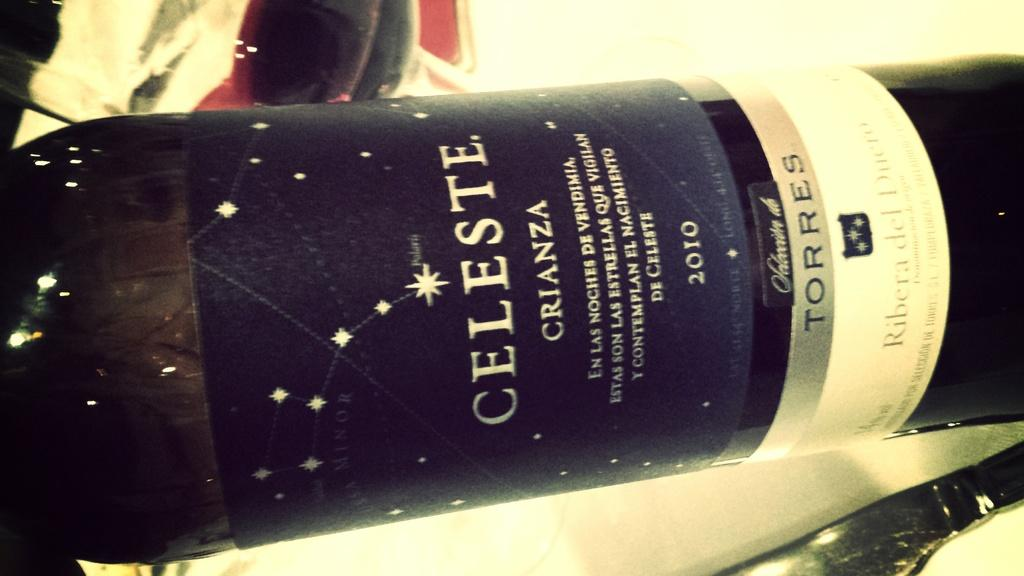<image>
Relay a brief, clear account of the picture shown. the word celeste that is on a wine bottle 